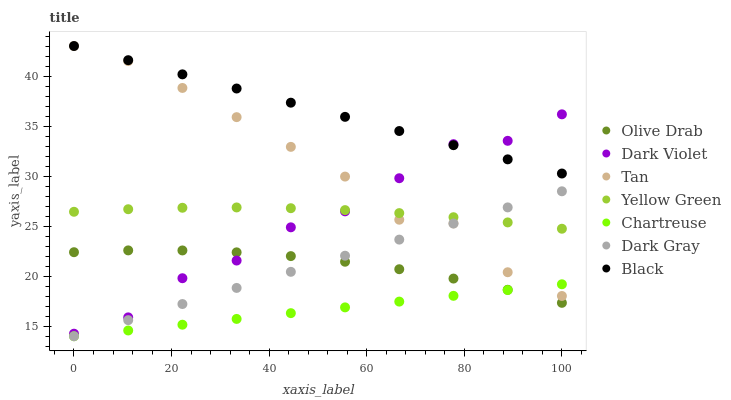Does Chartreuse have the minimum area under the curve?
Answer yes or no. Yes. Does Black have the maximum area under the curve?
Answer yes or no. Yes. Does Dark Violet have the minimum area under the curve?
Answer yes or no. No. Does Dark Violet have the maximum area under the curve?
Answer yes or no. No. Is Chartreuse the smoothest?
Answer yes or no. Yes. Is Dark Violet the roughest?
Answer yes or no. Yes. Is Dark Gray the smoothest?
Answer yes or no. No. Is Dark Gray the roughest?
Answer yes or no. No. Does Dark Gray have the lowest value?
Answer yes or no. Yes. Does Dark Violet have the lowest value?
Answer yes or no. No. Does Tan have the highest value?
Answer yes or no. Yes. Does Dark Violet have the highest value?
Answer yes or no. No. Is Yellow Green less than Black?
Answer yes or no. Yes. Is Yellow Green greater than Chartreuse?
Answer yes or no. Yes. Does Dark Gray intersect Yellow Green?
Answer yes or no. Yes. Is Dark Gray less than Yellow Green?
Answer yes or no. No. Is Dark Gray greater than Yellow Green?
Answer yes or no. No. Does Yellow Green intersect Black?
Answer yes or no. No. 